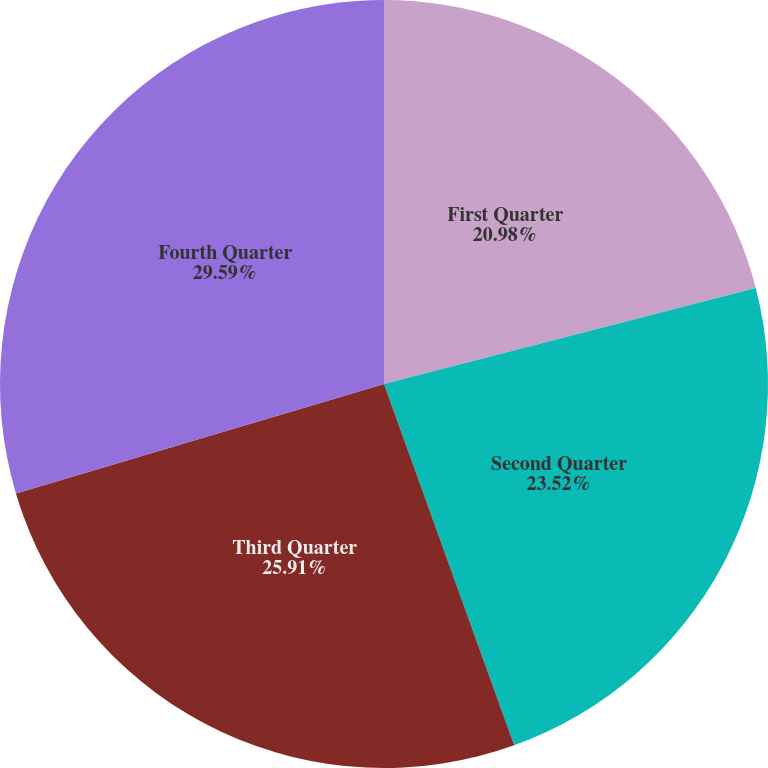Convert chart to OTSL. <chart><loc_0><loc_0><loc_500><loc_500><pie_chart><fcel>First Quarter<fcel>Second Quarter<fcel>Third Quarter<fcel>Fourth Quarter<nl><fcel>20.98%<fcel>23.52%<fcel>25.91%<fcel>29.6%<nl></chart> 